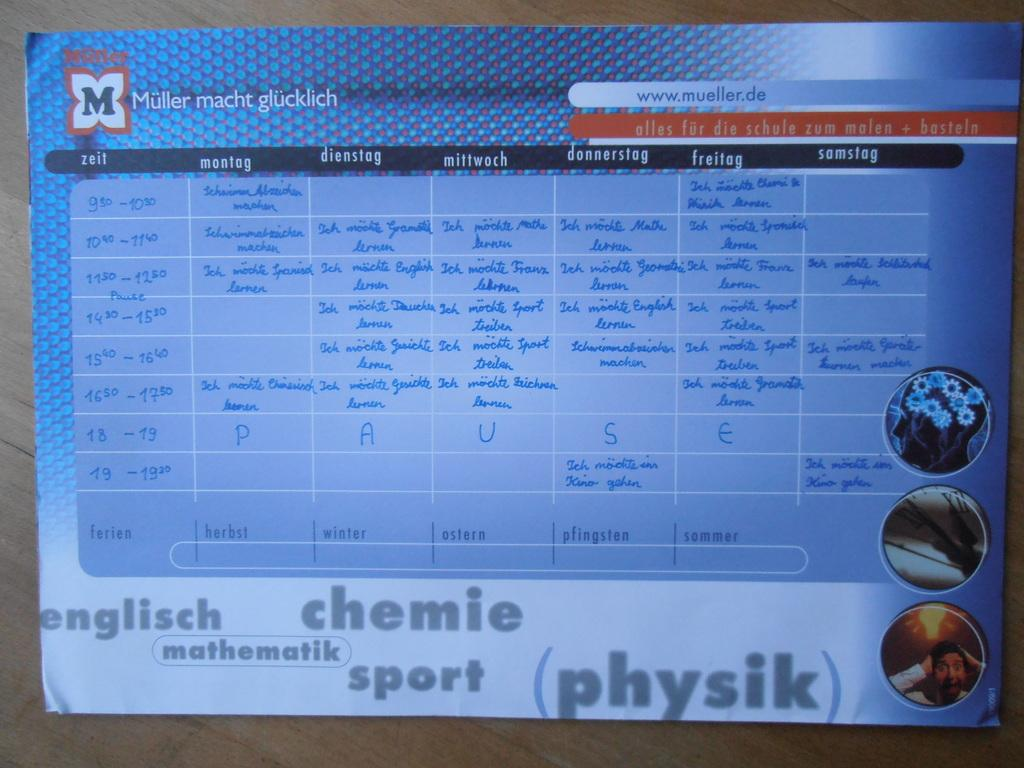What is present on the wall in the image? There is a poster on the wall in the image. What can be seen on the poster? The poster has pictures and text on it. How is the poster secured to the wall? The poster is attached to the wall. What type of flowers are growing on the poster in the image? There are no flowers present on the poster in the image; it features pictures and text. 